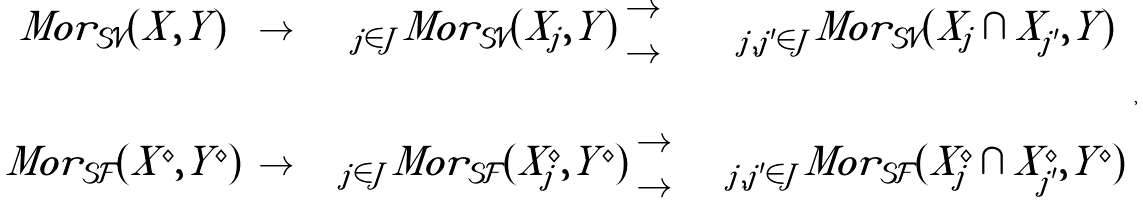Convert formula to latex. <formula><loc_0><loc_0><loc_500><loc_500>\begin{array} { c c c c } M o r _ { \mathcal { S V } } ( X , Y ) & \to & \prod _ { j \in J } M o r _ { \mathcal { S V } } ( X _ { j } , Y ) \begin{array} { c } \to \\ \to \end{array} & \prod _ { j , j ^ { \prime } \in J } M o r _ { \mathcal { S V } } ( X _ { j } \cap X _ { j ^ { \prime } } , Y ) \\ \downarrow & & \downarrow & \downarrow \\ M o r _ { \mathcal { S F } } ( X ^ { \diamond } , Y ^ { \diamond } ) & \to & \prod _ { j \in J } M o r _ { \mathcal { S F } } ( X _ { j } ^ { \diamond } , Y ^ { \diamond } ) \begin{array} { c } \to \\ \to \end{array} & \prod _ { j , j ^ { \prime } \in J } M o r _ { \mathcal { S F } } ( X _ { j } ^ { \diamond } \cap X _ { j ^ { \prime } } ^ { \diamond } , Y ^ { \diamond } ) \end{array} ,</formula> 